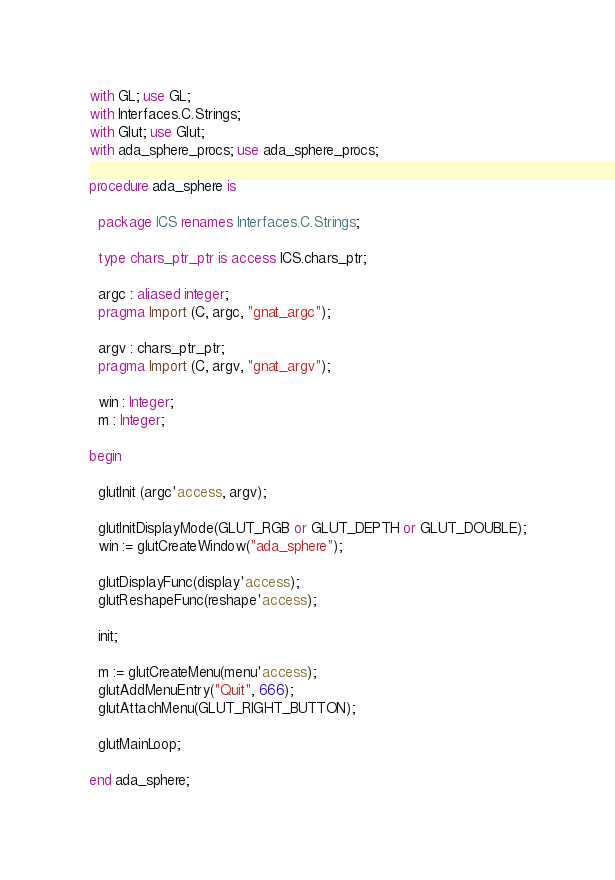Convert code to text. <code><loc_0><loc_0><loc_500><loc_500><_Ada_>
with GL; use GL;
with Interfaces.C.Strings;
with Glut; use Glut;
with ada_sphere_procs; use ada_sphere_procs;

procedure ada_sphere is
  
  package ICS renames Interfaces.C.Strings;

  type chars_ptr_ptr is access ICS.chars_ptr;

  argc : aliased integer;
  pragma Import (C, argc, "gnat_argc");

  argv : chars_ptr_ptr;
  pragma Import (C, argv, "gnat_argv");

  win : Integer;
  m : Integer;

begin

  glutInit (argc'access, argv);

  glutInitDisplayMode(GLUT_RGB or GLUT_DEPTH or GLUT_DOUBLE);
  win := glutCreateWindow("ada_sphere");

  glutDisplayFunc(display'access);
  glutReshapeFunc(reshape'access);

  init;

  m := glutCreateMenu(menu'access);
  glutAddMenuEntry("Quit", 666);
  glutAttachMenu(GLUT_RIGHT_BUTTON);

  glutMainLoop;

end ada_sphere;
</code> 